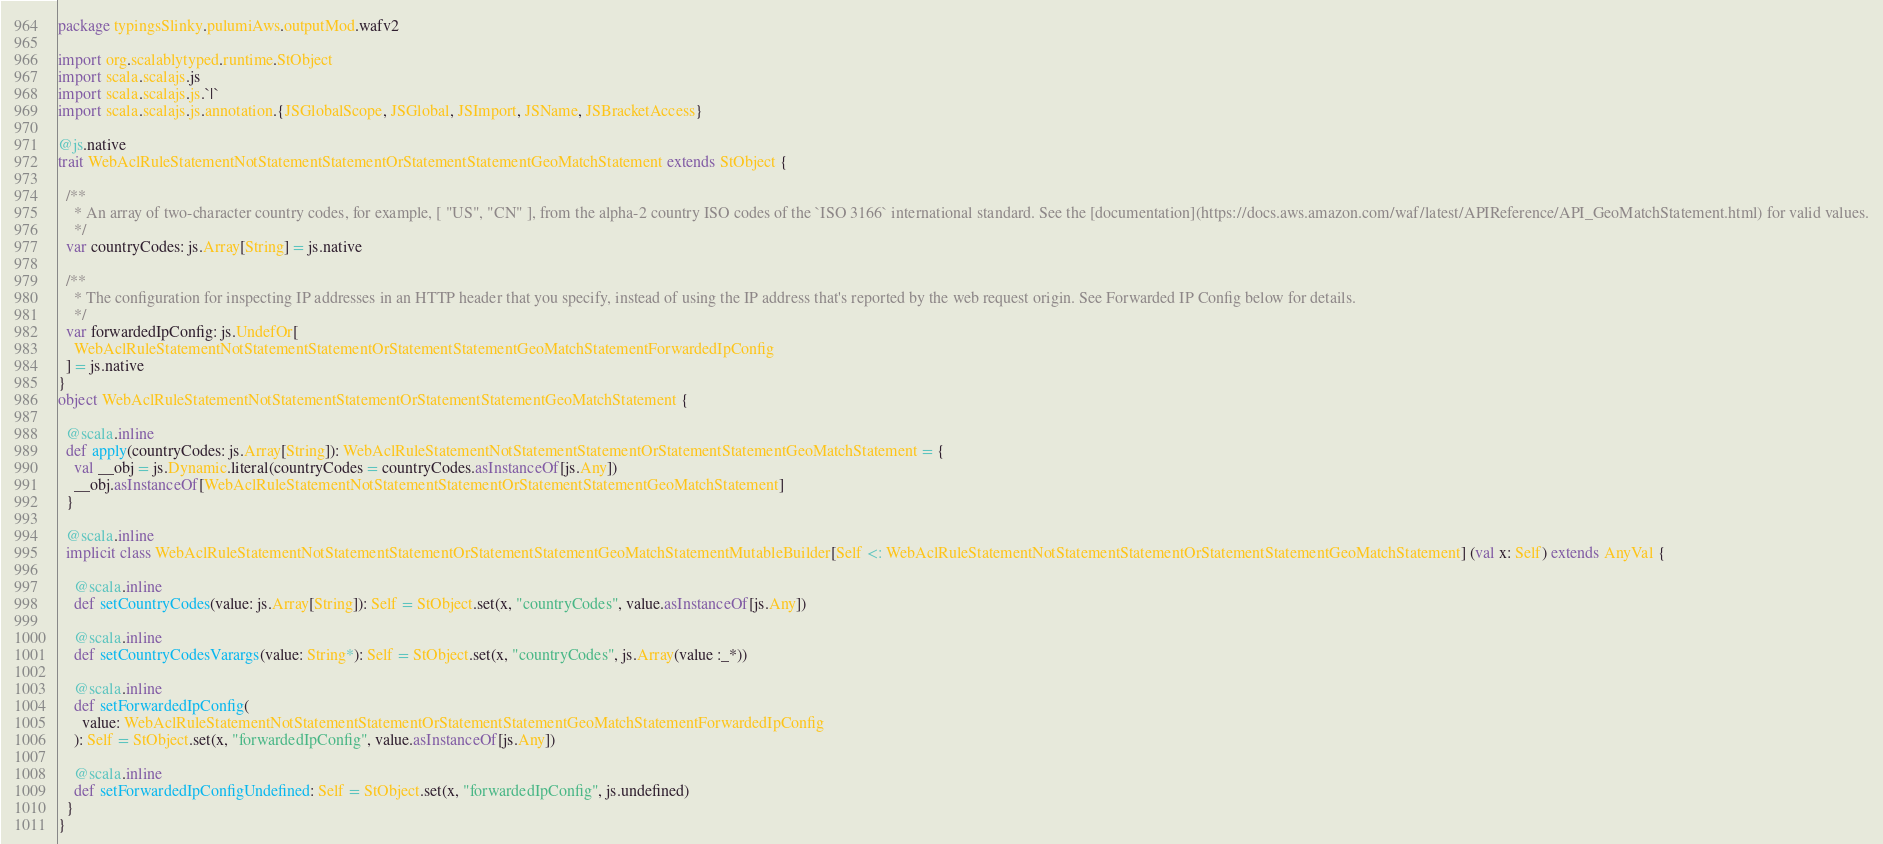<code> <loc_0><loc_0><loc_500><loc_500><_Scala_>package typingsSlinky.pulumiAws.outputMod.wafv2

import org.scalablytyped.runtime.StObject
import scala.scalajs.js
import scala.scalajs.js.`|`
import scala.scalajs.js.annotation.{JSGlobalScope, JSGlobal, JSImport, JSName, JSBracketAccess}

@js.native
trait WebAclRuleStatementNotStatementStatementOrStatementStatementGeoMatchStatement extends StObject {
  
  /**
    * An array of two-character country codes, for example, [ "US", "CN" ], from the alpha-2 country ISO codes of the `ISO 3166` international standard. See the [documentation](https://docs.aws.amazon.com/waf/latest/APIReference/API_GeoMatchStatement.html) for valid values.
    */
  var countryCodes: js.Array[String] = js.native
  
  /**
    * The configuration for inspecting IP addresses in an HTTP header that you specify, instead of using the IP address that's reported by the web request origin. See Forwarded IP Config below for details.
    */
  var forwardedIpConfig: js.UndefOr[
    WebAclRuleStatementNotStatementStatementOrStatementStatementGeoMatchStatementForwardedIpConfig
  ] = js.native
}
object WebAclRuleStatementNotStatementStatementOrStatementStatementGeoMatchStatement {
  
  @scala.inline
  def apply(countryCodes: js.Array[String]): WebAclRuleStatementNotStatementStatementOrStatementStatementGeoMatchStatement = {
    val __obj = js.Dynamic.literal(countryCodes = countryCodes.asInstanceOf[js.Any])
    __obj.asInstanceOf[WebAclRuleStatementNotStatementStatementOrStatementStatementGeoMatchStatement]
  }
  
  @scala.inline
  implicit class WebAclRuleStatementNotStatementStatementOrStatementStatementGeoMatchStatementMutableBuilder[Self <: WebAclRuleStatementNotStatementStatementOrStatementStatementGeoMatchStatement] (val x: Self) extends AnyVal {
    
    @scala.inline
    def setCountryCodes(value: js.Array[String]): Self = StObject.set(x, "countryCodes", value.asInstanceOf[js.Any])
    
    @scala.inline
    def setCountryCodesVarargs(value: String*): Self = StObject.set(x, "countryCodes", js.Array(value :_*))
    
    @scala.inline
    def setForwardedIpConfig(
      value: WebAclRuleStatementNotStatementStatementOrStatementStatementGeoMatchStatementForwardedIpConfig
    ): Self = StObject.set(x, "forwardedIpConfig", value.asInstanceOf[js.Any])
    
    @scala.inline
    def setForwardedIpConfigUndefined: Self = StObject.set(x, "forwardedIpConfig", js.undefined)
  }
}
</code> 